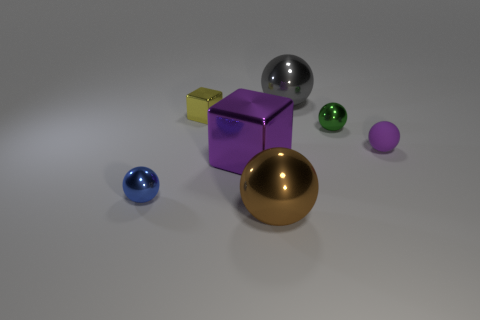Subtract all small blue spheres. How many spheres are left? 4 Add 1 yellow metallic cubes. How many objects exist? 8 Subtract all brown balls. How many balls are left? 4 Subtract all brown blocks. How many yellow spheres are left? 0 Subtract all large spheres. Subtract all purple objects. How many objects are left? 3 Add 2 small green balls. How many small green balls are left? 3 Add 7 large metal blocks. How many large metal blocks exist? 8 Subtract 1 gray balls. How many objects are left? 6 Subtract all spheres. How many objects are left? 2 Subtract 1 blocks. How many blocks are left? 1 